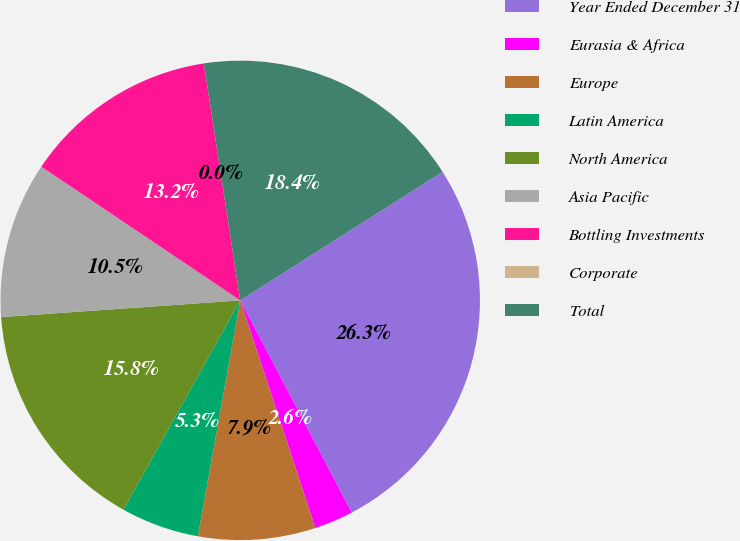Convert chart. <chart><loc_0><loc_0><loc_500><loc_500><pie_chart><fcel>Year Ended December 31<fcel>Eurasia & Africa<fcel>Europe<fcel>Latin America<fcel>North America<fcel>Asia Pacific<fcel>Bottling Investments<fcel>Corporate<fcel>Total<nl><fcel>26.31%<fcel>2.63%<fcel>7.9%<fcel>5.27%<fcel>15.79%<fcel>10.53%<fcel>13.16%<fcel>0.0%<fcel>18.42%<nl></chart> 